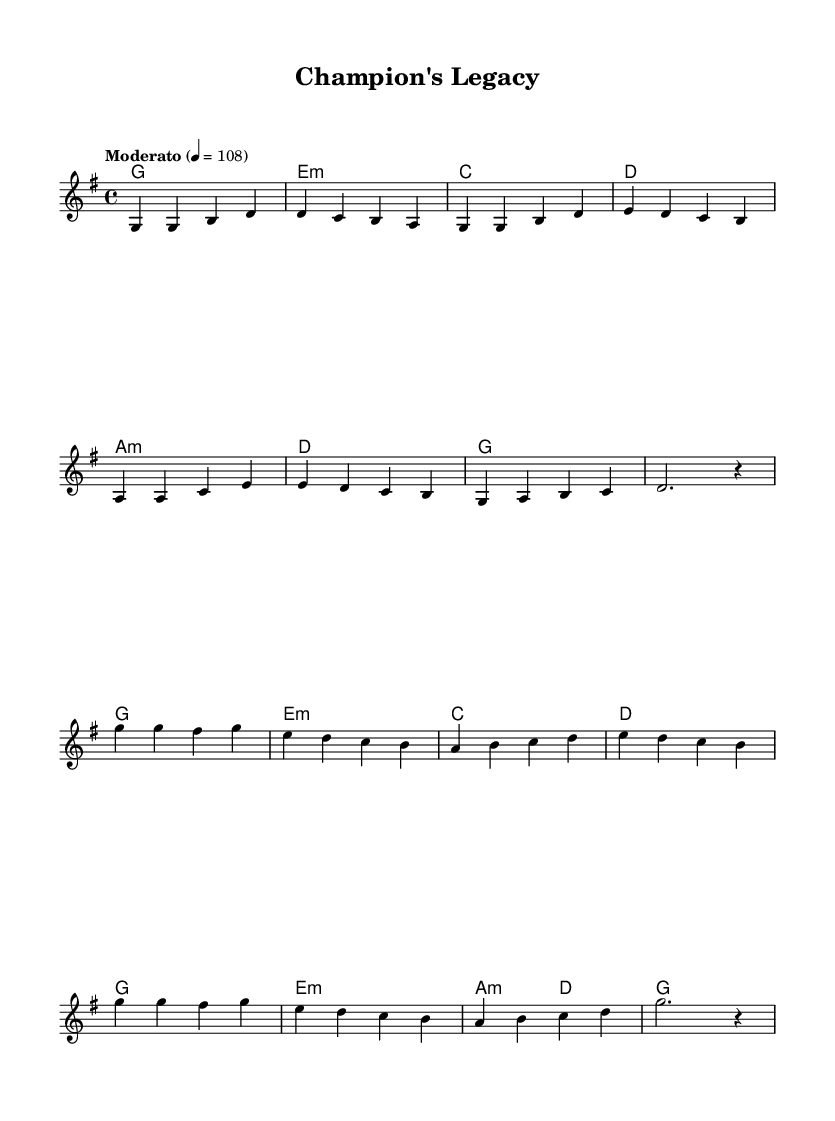What is the key signature of this music? The key signature displayed at the beginning of the score indicates that the piece is in G major, which has one sharp (F#).
Answer: G major What is the time signature of the piece? The time signature shown in the music indicates that it is written in 4/4 time, which means there are four beats in a measure and a quarter note receives one beat.
Answer: 4/4 What is the tempo marking of this piece? The tempo marking stated in the music is "Moderato," which typically suggests a moderate pace, and it is indicated with a metronome marking of 108 beats per minute.
Answer: Moderato 108 How many measures are in the verse section? By counting the measures in the verse part of the melody section, there are eight measures present before transitioning to the chorus.
Answer: Eight What is the harmonic structure of the chorus? The harmonic structure for the chorus consists of a progression that includes G, E minor, C, D, and finishes again on G, indicating a common pop progression in the key of G major.
Answer: G, E minor, C, D What type of lyrical theme is suggested in this K-Pop anthem? The title "Champion's Legacy" suggests themes of resilience and inspiration, celebrating the journey and accomplishments of retired athletes, which resonates with the K-Pop genre's focus on empowerment.
Answer: Resilience and inspiration What is the final note of the melody in the chorus? The final note of the melody in the chorus is a long held note indicated by the two dots, which is the G note, signaling the end of the section and rounding up the anthem.
Answer: G 